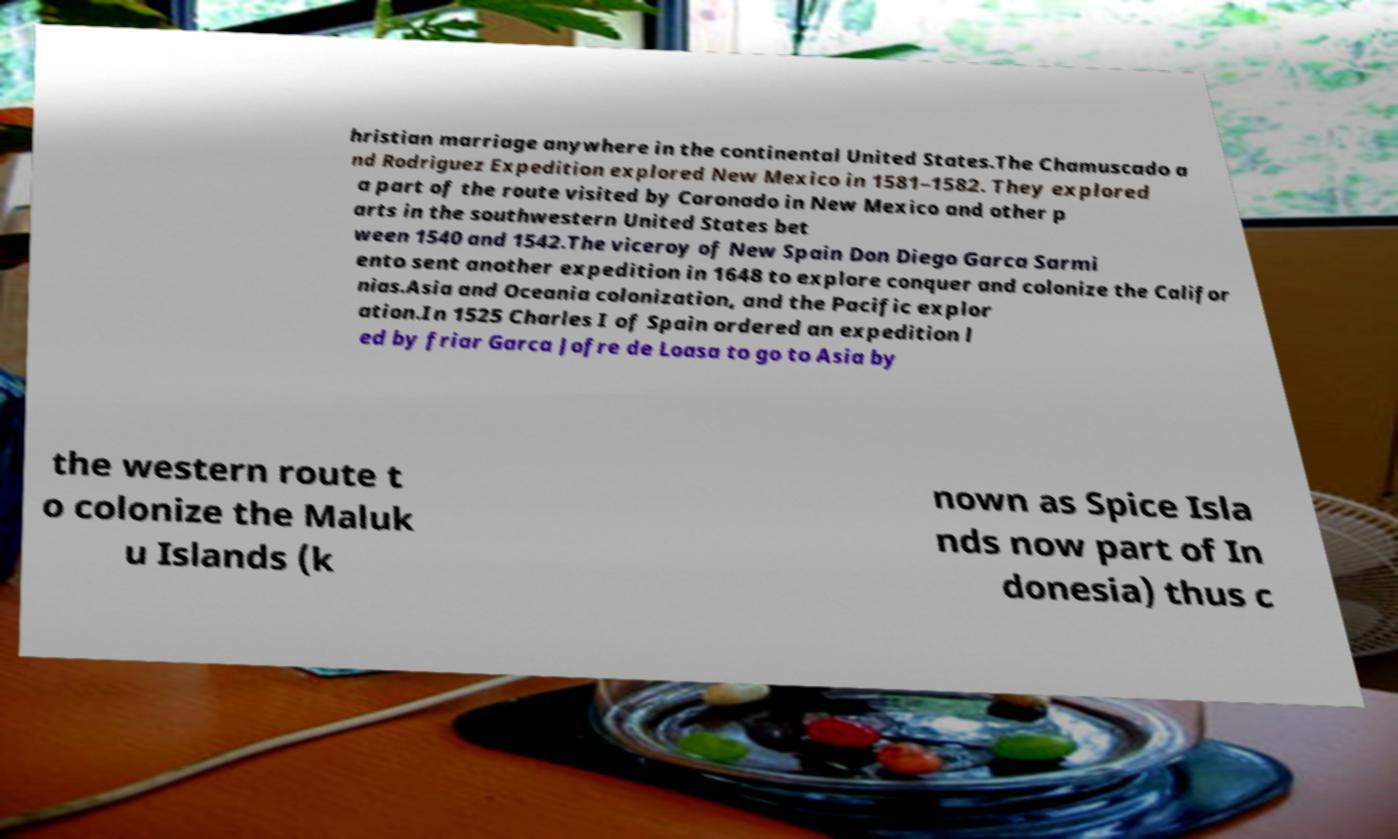I need the written content from this picture converted into text. Can you do that? hristian marriage anywhere in the continental United States.The Chamuscado a nd Rodriguez Expedition explored New Mexico in 1581–1582. They explored a part of the route visited by Coronado in New Mexico and other p arts in the southwestern United States bet ween 1540 and 1542.The viceroy of New Spain Don Diego Garca Sarmi ento sent another expedition in 1648 to explore conquer and colonize the Califor nias.Asia and Oceania colonization, and the Pacific explor ation.In 1525 Charles I of Spain ordered an expedition l ed by friar Garca Jofre de Loasa to go to Asia by the western route t o colonize the Maluk u Islands (k nown as Spice Isla nds now part of In donesia) thus c 